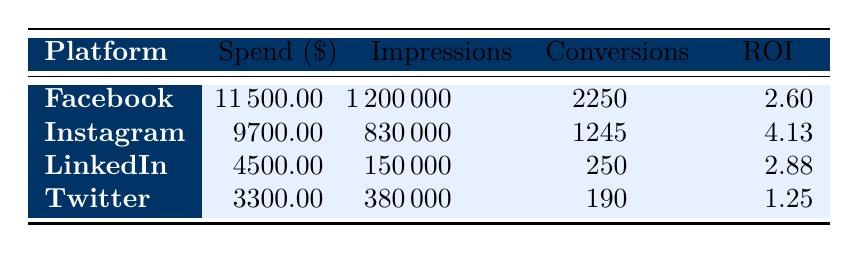What is the total spend on Facebook ads? To find the total spend on Facebook ads, we look at all the entries under the Facebook platform. The spend amounts for Facebook are 5000 and 4000 for different campaigns, and 2500 for another campaign, which adds up to 5000 + 4000 + 2500 = 11500.
Answer: 11500 What is the ROI for the Instagram campaigns? The ROI for Instagram campaigns must be collected from all Instagram entries: 4.14 for the Story campaign, 4 for the Carousel campaign, and 4.25 for the Video campaign. The average ROI is calculated as (4.14 + 4 + 4.25) / 3 = 4.13.
Answer: 4.13 Which platform had the highest total number of conversions? We need to sum the conversions for each platform: Facebook has 750 + 600 + 900 = 2250; Instagram has 450 + 375 + 420 = 1245; LinkedIn has 150 + 100 = 250; Twitter has 100 + 90 = 190. The highest total is from Facebook with 2250 conversions.
Answer: Facebook Is the Twitter ROI higher than the LinkedIn ROI? The ROI for Twitter is 1 and for LinkedIn it is 2.75. Since 1 is less than 2.75, the statement is false.
Answer: No What is the average spend across all platforms? To calculate the average spend, we sum all spend values: 5000 + 3500 + 2000 + 1500 + 4000 + 3000 + 2500 + 1800 + 2500 + 3200 = 22,500. There are 10 campaigns in total, so the average spend is 22,500 / 10 = 2250.
Answer: 2250 What percentage of the total spend is from Instagram? The total spend is 22,500 and Instagram's spend amounts to 3500 + 3000 + 3200 = 9700. To find the percentage, we calculate (9700 / 22500) * 100 = 43.11%.
Answer: 43.11% Which ad format on Facebook had the highest ROI? Among Facebook ads, we have two ROI values of 3.5 (Carousel and Video) and 0.8 (Lead Ad). Both the Carousel and Video formats have the highest ROI of 3.5.
Answer: Carousel and Video How many total impressions were garnered by LinkedIn ads? For LinkedIn, there are two entries: 100000 impressions from Sponsored Content and 50000 impressions from InMail, summing these gives 100000 + 50000 = 150000 impressions.
Answer: 150000 